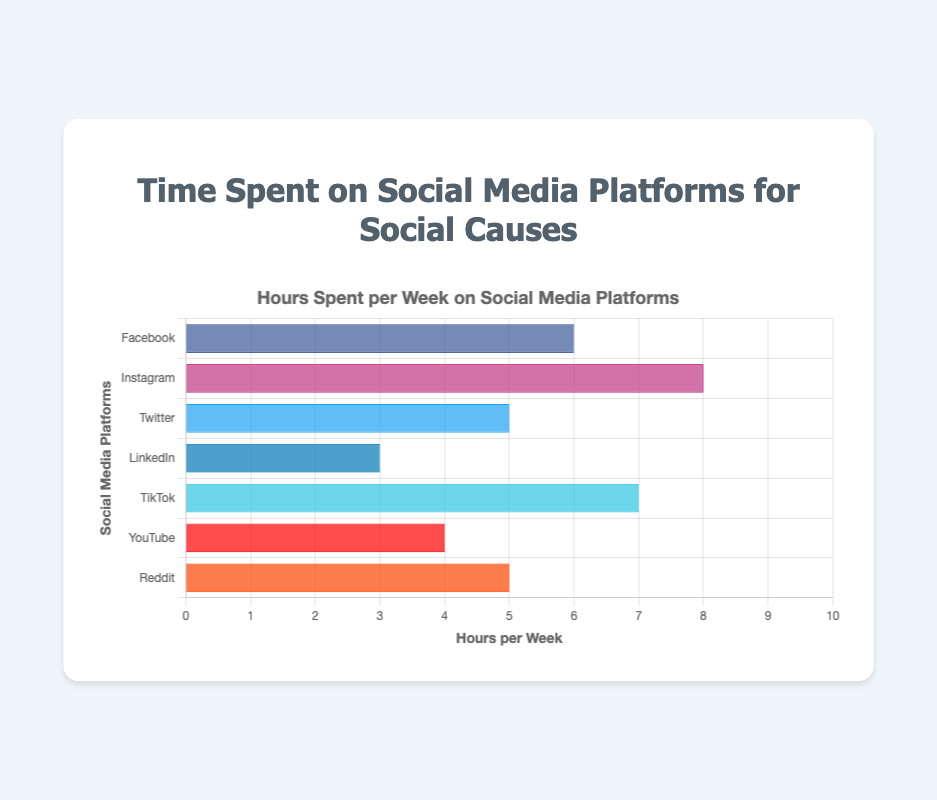What is the total number of hours spent per week on Instagram and TikTok combined? Add the total hours per week for Instagram (8) and TikTok (7); 8 + 7 = 15
Answer: 15 Which platform has the least average daily sessions? From the data: Facebook (4), Instagram (6), Twitter (7), LinkedIn (2), TikTok (5), YouTube (3), Reddit (4). LinkedIn has the least (2).
Answer: LinkedIn Which platform has more hours spent per week, Facebook or YouTube? Facebook has 6 hours per week and YouTube has 4 hours per week, so Facebook has more hours.
Answer: Facebook How many more hours per week are spent on Instagram than on Twitter? Instagram has 8 hours per week and Twitter has 5 hours per week; 8 - 5 = 3
Answer: 3 Rank the platforms by total hours per week, starting from the highest. Instagram (8), TikTok (7), Facebook (6), Twitter and Reddit (5), YouTube (4), LinkedIn (3)
Answer: Instagram, TikTok, Facebook, Twitter/Reddit, YouTube, LinkedIn What is the difference in total hours per week between the platform with the highest and lowest values? The highest is Instagram (8) and the lowest is LinkedIn (3); 8 - 3 = 5
Answer: 5 Which two platforms have the same total hours per week? Twitter and Reddit both have 5 total hours per week.
Answer: Twitter, Reddit How does the total number of hours spent on social media for social causes compare to the total number of support actions recorded? (Choose one platform) For Facebook: Total hours/week = 6; Total support actions = Posts Shared (5) + Campaigns Organized (2) + Fundraisers Created (1) = 8. 6 hours compared to 8 support actions.
Answer: Facebook: 6 hours, 8 actions Which platform has a higher involvement in creating multimedia content (videos and images) for social causes, Instagram or YouTube? Instagram: Stories Posted (10) + Live Videos Hosted (3) = 13; YouTube: Videos Uploaded (3) + Playlists Curated (2) = 5; Instagram has higher involvement.
Answer: Instagram 